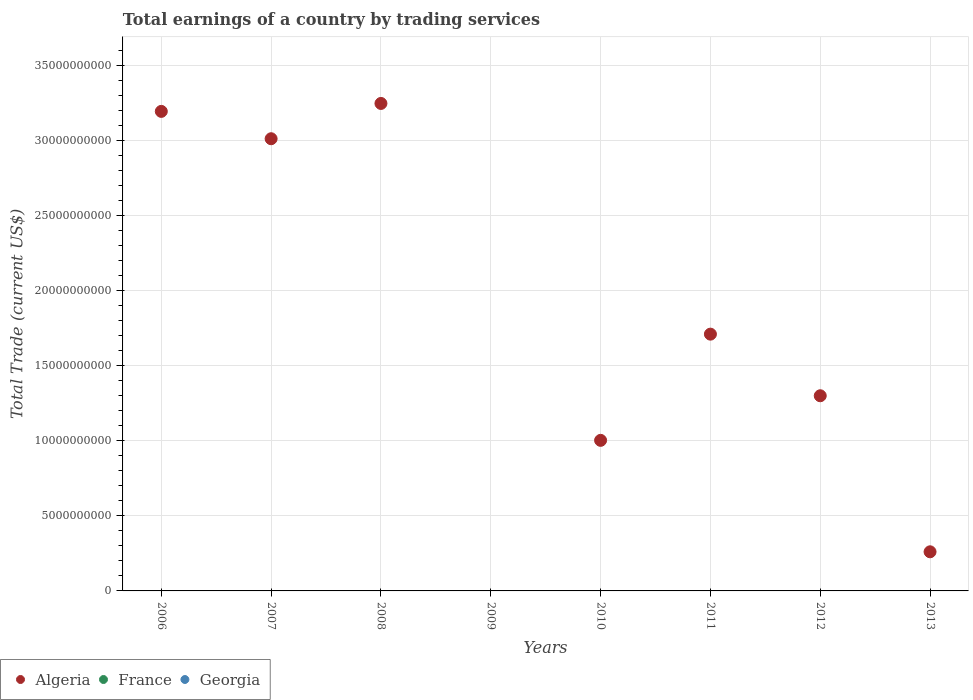What is the total earnings in France in 2011?
Offer a very short reply. 0. Across all years, what is the maximum total earnings in Algeria?
Your answer should be very brief. 3.25e+1. What is the total total earnings in Algeria in the graph?
Provide a succinct answer. 1.37e+11. What is the difference between the total earnings in Algeria in 2008 and that in 2012?
Give a very brief answer. 1.95e+1. What is the difference between the total earnings in Georgia in 2006 and the total earnings in Algeria in 2007?
Your answer should be very brief. -3.01e+1. What is the average total earnings in France per year?
Your answer should be very brief. 0. Is the total earnings in Algeria in 2007 less than that in 2011?
Provide a short and direct response. No. What is the difference between the highest and the second highest total earnings in Algeria?
Offer a terse response. 5.29e+08. What is the difference between the highest and the lowest total earnings in Algeria?
Offer a terse response. 3.25e+1. Is the sum of the total earnings in Algeria in 2008 and 2011 greater than the maximum total earnings in Georgia across all years?
Give a very brief answer. Yes. Does the total earnings in Georgia monotonically increase over the years?
Offer a terse response. No. Is the total earnings in Algeria strictly less than the total earnings in Georgia over the years?
Keep it short and to the point. No. How many dotlines are there?
Give a very brief answer. 1. How many years are there in the graph?
Make the answer very short. 8. What is the difference between two consecutive major ticks on the Y-axis?
Offer a very short reply. 5.00e+09. Does the graph contain grids?
Ensure brevity in your answer.  Yes. How many legend labels are there?
Make the answer very short. 3. How are the legend labels stacked?
Provide a short and direct response. Horizontal. What is the title of the graph?
Give a very brief answer. Total earnings of a country by trading services. What is the label or title of the X-axis?
Offer a very short reply. Years. What is the label or title of the Y-axis?
Ensure brevity in your answer.  Total Trade (current US$). What is the Total Trade (current US$) of Algeria in 2006?
Keep it short and to the point. 3.19e+1. What is the Total Trade (current US$) of Algeria in 2007?
Make the answer very short. 3.01e+1. What is the Total Trade (current US$) of France in 2007?
Give a very brief answer. 0. What is the Total Trade (current US$) of Algeria in 2008?
Make the answer very short. 3.25e+1. What is the Total Trade (current US$) of France in 2009?
Ensure brevity in your answer.  0. What is the Total Trade (current US$) of Georgia in 2009?
Your answer should be compact. 0. What is the Total Trade (current US$) in Algeria in 2010?
Keep it short and to the point. 1.00e+1. What is the Total Trade (current US$) in France in 2010?
Keep it short and to the point. 0. What is the Total Trade (current US$) of Georgia in 2010?
Offer a very short reply. 0. What is the Total Trade (current US$) in Algeria in 2011?
Give a very brief answer. 1.71e+1. What is the Total Trade (current US$) in France in 2011?
Your answer should be compact. 0. What is the Total Trade (current US$) in Algeria in 2012?
Ensure brevity in your answer.  1.30e+1. What is the Total Trade (current US$) of France in 2012?
Give a very brief answer. 0. What is the Total Trade (current US$) in Georgia in 2012?
Make the answer very short. 0. What is the Total Trade (current US$) in Algeria in 2013?
Keep it short and to the point. 2.61e+09. Across all years, what is the maximum Total Trade (current US$) in Algeria?
Your answer should be compact. 3.25e+1. What is the total Total Trade (current US$) in Algeria in the graph?
Give a very brief answer. 1.37e+11. What is the total Total Trade (current US$) in France in the graph?
Make the answer very short. 0. What is the difference between the Total Trade (current US$) of Algeria in 2006 and that in 2007?
Offer a very short reply. 1.82e+09. What is the difference between the Total Trade (current US$) in Algeria in 2006 and that in 2008?
Give a very brief answer. -5.29e+08. What is the difference between the Total Trade (current US$) of Algeria in 2006 and that in 2010?
Keep it short and to the point. 2.19e+1. What is the difference between the Total Trade (current US$) in Algeria in 2006 and that in 2011?
Give a very brief answer. 1.48e+1. What is the difference between the Total Trade (current US$) of Algeria in 2006 and that in 2012?
Your answer should be very brief. 1.89e+1. What is the difference between the Total Trade (current US$) in Algeria in 2006 and that in 2013?
Provide a short and direct response. 2.93e+1. What is the difference between the Total Trade (current US$) of Algeria in 2007 and that in 2008?
Provide a short and direct response. -2.35e+09. What is the difference between the Total Trade (current US$) in Algeria in 2007 and that in 2010?
Offer a terse response. 2.01e+1. What is the difference between the Total Trade (current US$) of Algeria in 2007 and that in 2011?
Your answer should be very brief. 1.30e+1. What is the difference between the Total Trade (current US$) of Algeria in 2007 and that in 2012?
Make the answer very short. 1.71e+1. What is the difference between the Total Trade (current US$) of Algeria in 2007 and that in 2013?
Provide a short and direct response. 2.75e+1. What is the difference between the Total Trade (current US$) of Algeria in 2008 and that in 2010?
Your response must be concise. 2.24e+1. What is the difference between the Total Trade (current US$) in Algeria in 2008 and that in 2011?
Make the answer very short. 1.54e+1. What is the difference between the Total Trade (current US$) in Algeria in 2008 and that in 2012?
Your answer should be compact. 1.95e+1. What is the difference between the Total Trade (current US$) of Algeria in 2008 and that in 2013?
Your answer should be very brief. 2.99e+1. What is the difference between the Total Trade (current US$) of Algeria in 2010 and that in 2011?
Give a very brief answer. -7.08e+09. What is the difference between the Total Trade (current US$) in Algeria in 2010 and that in 2012?
Make the answer very short. -2.97e+09. What is the difference between the Total Trade (current US$) in Algeria in 2010 and that in 2013?
Your answer should be compact. 7.42e+09. What is the difference between the Total Trade (current US$) of Algeria in 2011 and that in 2012?
Your answer should be very brief. 4.10e+09. What is the difference between the Total Trade (current US$) in Algeria in 2011 and that in 2013?
Give a very brief answer. 1.45e+1. What is the difference between the Total Trade (current US$) in Algeria in 2012 and that in 2013?
Keep it short and to the point. 1.04e+1. What is the average Total Trade (current US$) in Algeria per year?
Provide a short and direct response. 1.72e+1. What is the average Total Trade (current US$) in France per year?
Offer a very short reply. 0. What is the average Total Trade (current US$) in Georgia per year?
Give a very brief answer. 0. What is the ratio of the Total Trade (current US$) in Algeria in 2006 to that in 2007?
Provide a short and direct response. 1.06. What is the ratio of the Total Trade (current US$) in Algeria in 2006 to that in 2008?
Offer a very short reply. 0.98. What is the ratio of the Total Trade (current US$) in Algeria in 2006 to that in 2010?
Ensure brevity in your answer.  3.18. What is the ratio of the Total Trade (current US$) in Algeria in 2006 to that in 2011?
Keep it short and to the point. 1.87. What is the ratio of the Total Trade (current US$) of Algeria in 2006 to that in 2012?
Keep it short and to the point. 2.46. What is the ratio of the Total Trade (current US$) in Algeria in 2006 to that in 2013?
Your answer should be compact. 12.26. What is the ratio of the Total Trade (current US$) of Algeria in 2007 to that in 2008?
Your response must be concise. 0.93. What is the ratio of the Total Trade (current US$) of Algeria in 2007 to that in 2010?
Your answer should be compact. 3. What is the ratio of the Total Trade (current US$) of Algeria in 2007 to that in 2011?
Your response must be concise. 1.76. What is the ratio of the Total Trade (current US$) in Algeria in 2007 to that in 2012?
Ensure brevity in your answer.  2.32. What is the ratio of the Total Trade (current US$) in Algeria in 2007 to that in 2013?
Provide a short and direct response. 11.56. What is the ratio of the Total Trade (current US$) of Algeria in 2008 to that in 2010?
Your answer should be compact. 3.24. What is the ratio of the Total Trade (current US$) of Algeria in 2008 to that in 2011?
Your response must be concise. 1.9. What is the ratio of the Total Trade (current US$) of Algeria in 2008 to that in 2012?
Your answer should be compact. 2.5. What is the ratio of the Total Trade (current US$) of Algeria in 2008 to that in 2013?
Provide a succinct answer. 12.46. What is the ratio of the Total Trade (current US$) of Algeria in 2010 to that in 2011?
Make the answer very short. 0.59. What is the ratio of the Total Trade (current US$) in Algeria in 2010 to that in 2012?
Offer a terse response. 0.77. What is the ratio of the Total Trade (current US$) in Algeria in 2010 to that in 2013?
Offer a terse response. 3.85. What is the ratio of the Total Trade (current US$) of Algeria in 2011 to that in 2012?
Offer a very short reply. 1.32. What is the ratio of the Total Trade (current US$) of Algeria in 2011 to that in 2013?
Provide a short and direct response. 6.56. What is the ratio of the Total Trade (current US$) in Algeria in 2012 to that in 2013?
Your response must be concise. 4.99. What is the difference between the highest and the second highest Total Trade (current US$) in Algeria?
Provide a short and direct response. 5.29e+08. What is the difference between the highest and the lowest Total Trade (current US$) in Algeria?
Your answer should be compact. 3.25e+1. 